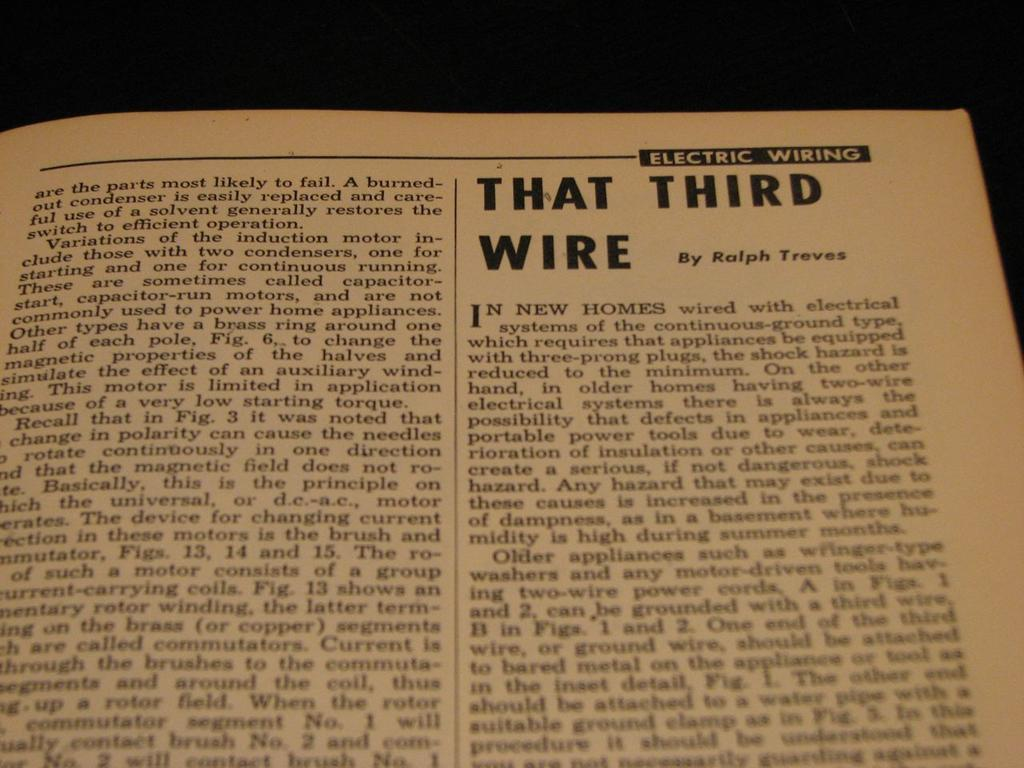<image>
Share a concise interpretation of the image provided. Page from a book that has the words "That Third Wire" in bold. 